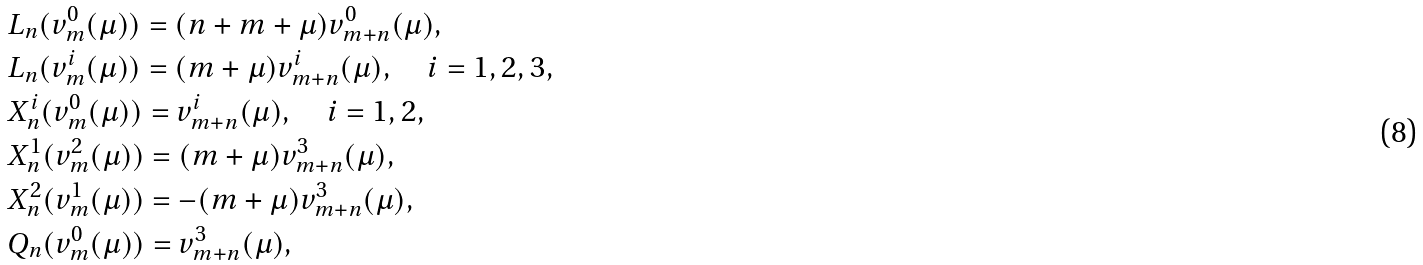Convert formula to latex. <formula><loc_0><loc_0><loc_500><loc_500>& L _ { n } ( v _ { m } ^ { 0 } ( \mu ) ) = ( n + m + \mu ) v _ { m + n } ^ { 0 } ( \mu ) , \\ & L _ { n } ( v _ { m } ^ { i } ( \mu ) ) = ( m + \mu ) v _ { m + n } ^ { i } ( \mu ) , \quad i = 1 , 2 , 3 , \\ & X _ { n } ^ { i } ( v _ { m } ^ { 0 } ( \mu ) ) = v _ { m + n } ^ { i } ( \mu ) , \quad i = 1 , 2 , \\ & X _ { n } ^ { 1 } ( v _ { m } ^ { 2 } ( \mu ) ) = ( m + \mu ) v _ { m + n } ^ { 3 } ( \mu ) , \\ & X _ { n } ^ { 2 } ( v _ { m } ^ { 1 } ( \mu ) ) = - ( m + \mu ) v _ { m + n } ^ { 3 } ( \mu ) , \\ & Q _ { n } ( v _ { m } ^ { 0 } ( \mu ) ) = v _ { m + n } ^ { 3 } ( \mu ) ,</formula> 